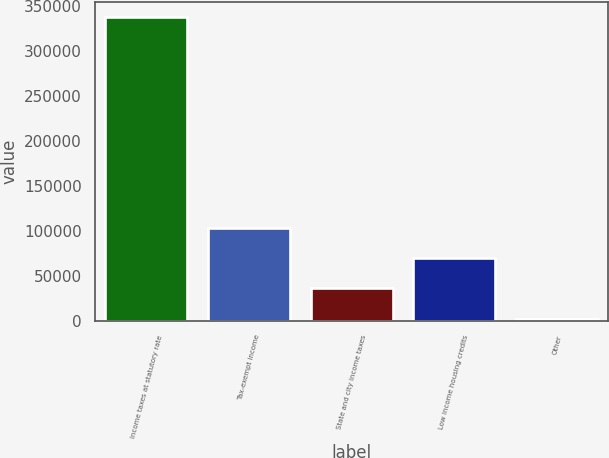Convert chart to OTSL. <chart><loc_0><loc_0><loc_500><loc_500><bar_chart><fcel>Income taxes at statutory rate<fcel>Tax-exempt income<fcel>State and city income taxes<fcel>Low income housing credits<fcel>Other<nl><fcel>337238<fcel>103154<fcel>36273.5<fcel>69714<fcel>2833<nl></chart> 